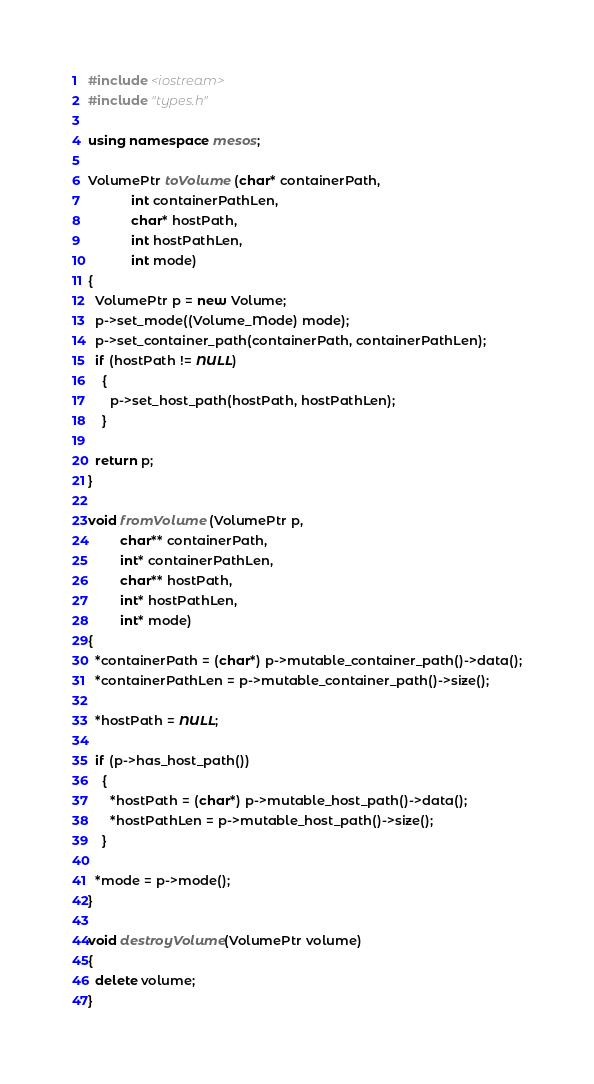Convert code to text. <code><loc_0><loc_0><loc_500><loc_500><_C++_>#include <iostream>
#include "types.h"

using namespace mesos;

VolumePtr toVolume (char* containerPath,
		    int containerPathLen,
		    char* hostPath,
		    int hostPathLen,
		    int mode)
{
  VolumePtr p = new Volume;
  p->set_mode((Volume_Mode) mode);
  p->set_container_path(containerPath, containerPathLen);
  if (hostPath != NULL)
    {
      p->set_host_path(hostPath, hostPathLen);
    }

  return p;
}

void fromVolume (VolumePtr p,
		 char** containerPath,
		 int* containerPathLen,
		 char** hostPath,
		 int* hostPathLen,
		 int* mode)
{
  *containerPath = (char*) p->mutable_container_path()->data();
  *containerPathLen = p->mutable_container_path()->size();

  *hostPath = NULL;

  if (p->has_host_path())
    {
      *hostPath = (char*) p->mutable_host_path()->data();
      *hostPathLen = p->mutable_host_path()->size();
    }

  *mode = p->mode();
}

void destroyVolume(VolumePtr volume)
{
  delete volume;
}
</code> 